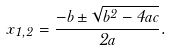<formula> <loc_0><loc_0><loc_500><loc_500>x _ { 1 , 2 } = \frac { - b \pm \sqrt { b ^ { 2 } - 4 a c } } { 2 a } .</formula> 